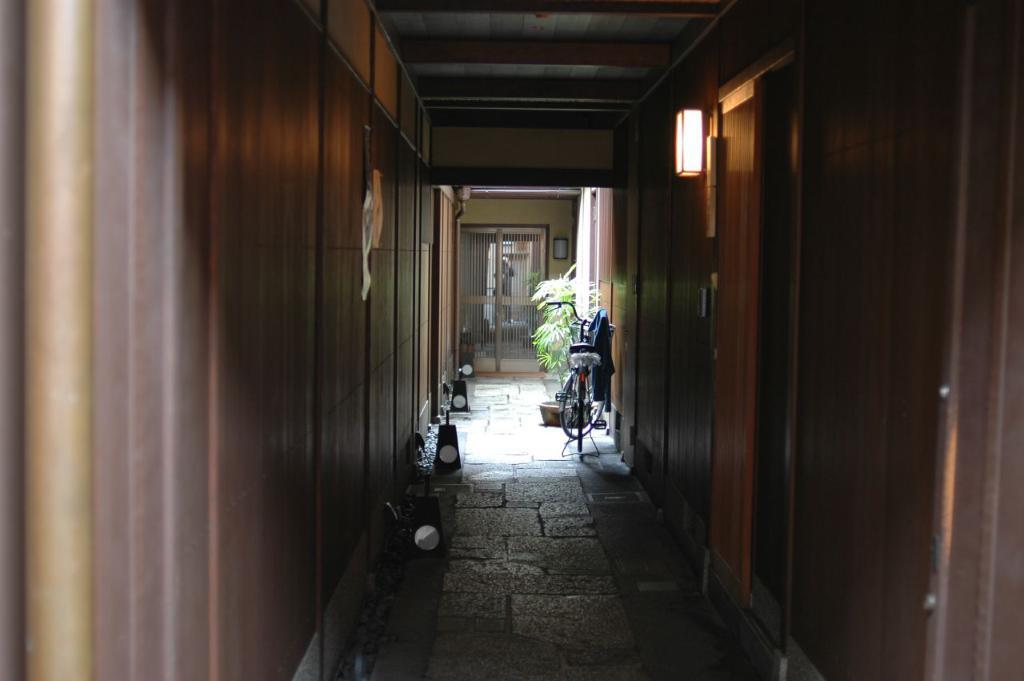What type of material is used for the doors and walls in the image? The doors and walls in the image are made of wood. What can be seen in the image that allows light and air to enter the space? There are windows in the image. What provides illumination in the image? There are lights in the image. What mode of transportation is visible in the image? There is a bicycle in the image. What type of decorative item is present in the image? There is a flower pot in the image. What type of fruit is hanging from the flowering from the bicycle in the image? There is no fruit or flowering item hanging from the bicycle in the image; it is a mode of transportation, and the image does not depict any fruit or flowers. 